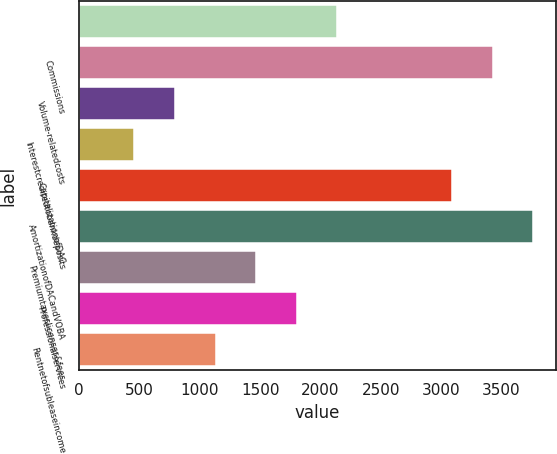Convert chart. <chart><loc_0><loc_0><loc_500><loc_500><bar_chart><ecel><fcel>Commissions<fcel>Volume-relatedcosts<fcel>Interestcreditedtobankdeposits<fcel>CapitalizationofDAC<fcel>AmortizationofDACandVOBA<fcel>Premiumtaxeslicenses&fees<fcel>Professionalservices<fcel>Rentnetofsubleaseincome<nl><fcel>2141.4<fcel>3428.9<fcel>793.8<fcel>456.9<fcel>3092<fcel>3765.8<fcel>1467.6<fcel>1804.5<fcel>1130.7<nl></chart> 